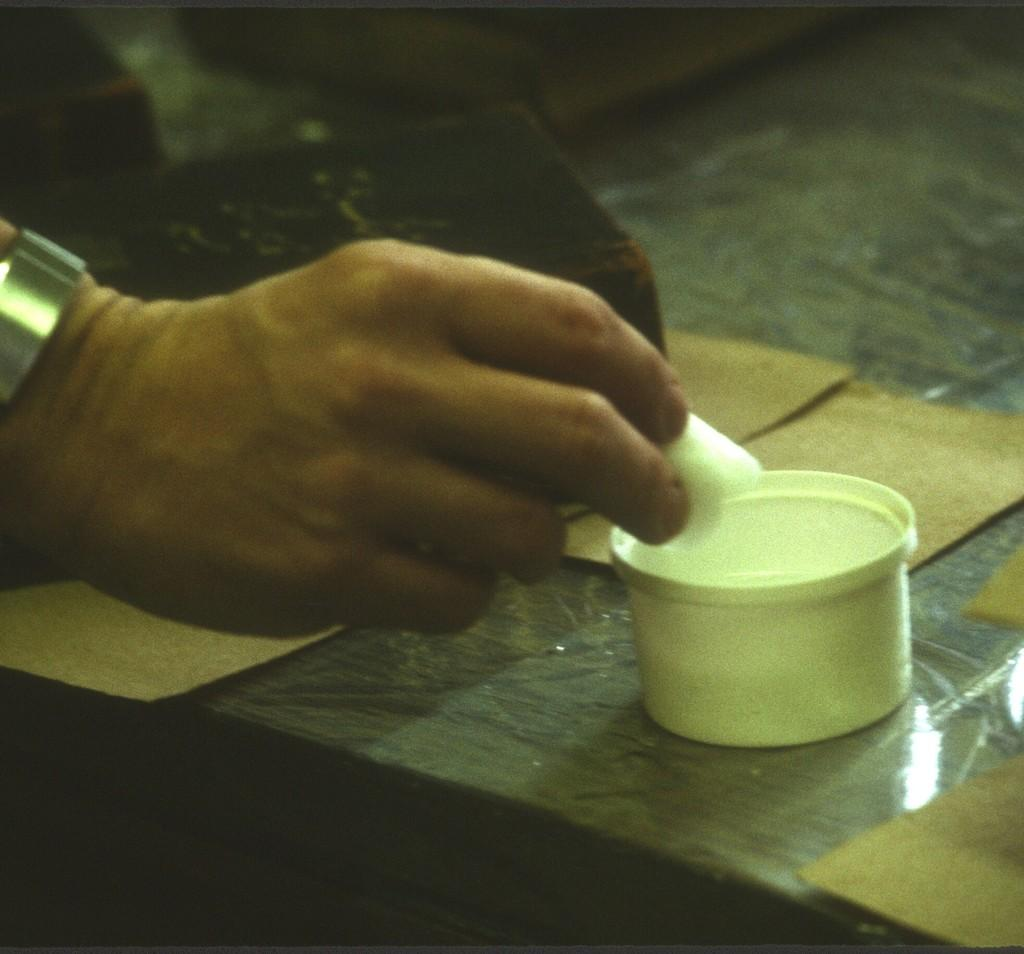What can be seen in the image? There is a person in the image. What is the person holding? The person is holding an object. What type of objects can be seen in the image besides the person and the object they are holding? There are boards, a bowl, and other objects on the surface in the image. What type of jam is being served in the image? There is no jam present in the image. 